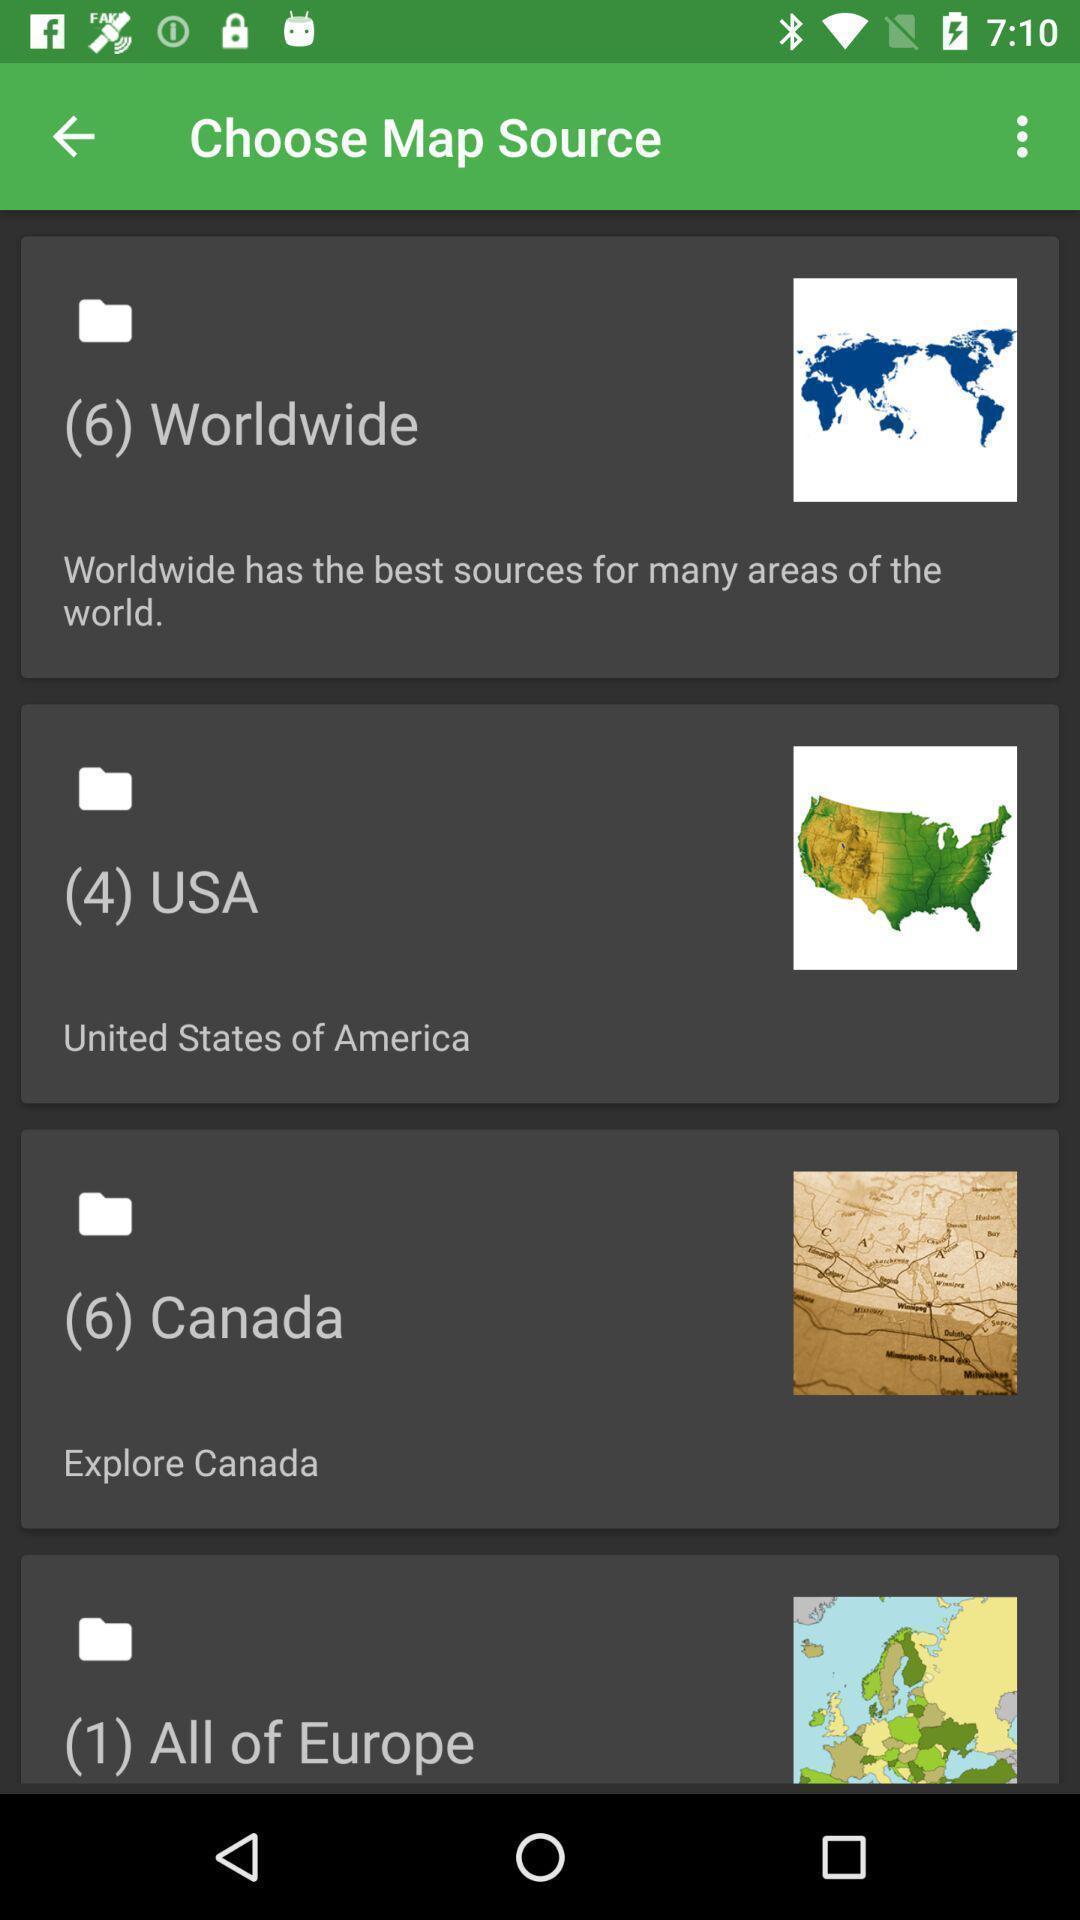Provide a description of this screenshot. Page showing to choose map source. 